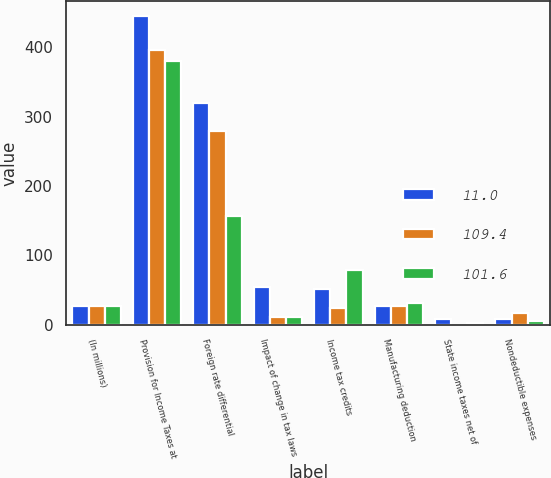Convert chart. <chart><loc_0><loc_0><loc_500><loc_500><stacked_bar_chart><ecel><fcel>(In millions)<fcel>Provision for Income Taxes at<fcel>Foreign rate differential<fcel>Impact of change in tax laws<fcel>Income tax credits<fcel>Manufacturing deduction<fcel>State income taxes net of<fcel>Nondeductible expenses<nl><fcel>11<fcel>27.3<fcel>444.3<fcel>319.5<fcel>53.7<fcel>52.1<fcel>27.3<fcel>8.6<fcel>8.1<nl><fcel>109.4<fcel>27.3<fcel>396.5<fcel>279.6<fcel>11.7<fcel>24.8<fcel>27<fcel>0.3<fcel>17.5<nl><fcel>101.6<fcel>27.3<fcel>380.7<fcel>156<fcel>11<fcel>79.5<fcel>31.5<fcel>2.8<fcel>5.8<nl></chart> 